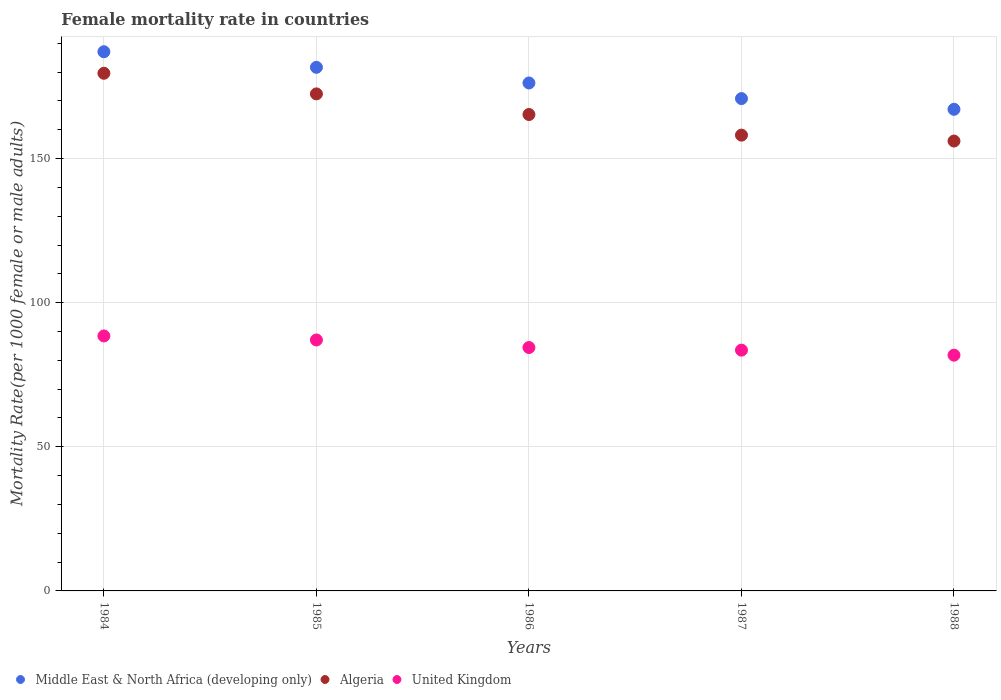Is the number of dotlines equal to the number of legend labels?
Give a very brief answer. Yes. What is the female mortality rate in United Kingdom in 1988?
Offer a very short reply. 81.79. Across all years, what is the maximum female mortality rate in Algeria?
Your answer should be compact. 179.58. Across all years, what is the minimum female mortality rate in United Kingdom?
Your answer should be compact. 81.79. In which year was the female mortality rate in Middle East & North Africa (developing only) maximum?
Your answer should be very brief. 1984. What is the total female mortality rate in Middle East & North Africa (developing only) in the graph?
Make the answer very short. 882.79. What is the difference between the female mortality rate in Algeria in 1984 and that in 1988?
Ensure brevity in your answer.  23.52. What is the difference between the female mortality rate in United Kingdom in 1984 and the female mortality rate in Algeria in 1986?
Give a very brief answer. -76.82. What is the average female mortality rate in Middle East & North Africa (developing only) per year?
Ensure brevity in your answer.  176.56. In the year 1986, what is the difference between the female mortality rate in Middle East & North Africa (developing only) and female mortality rate in United Kingdom?
Give a very brief answer. 91.77. In how many years, is the female mortality rate in Algeria greater than 30?
Give a very brief answer. 5. What is the ratio of the female mortality rate in Middle East & North Africa (developing only) in 1984 to that in 1988?
Your answer should be compact. 1.12. What is the difference between the highest and the second highest female mortality rate in Algeria?
Keep it short and to the point. 7.16. What is the difference between the highest and the lowest female mortality rate in Middle East & North Africa (developing only)?
Offer a very short reply. 19.97. In how many years, is the female mortality rate in United Kingdom greater than the average female mortality rate in United Kingdom taken over all years?
Keep it short and to the point. 2. Does the female mortality rate in Middle East & North Africa (developing only) monotonically increase over the years?
Offer a very short reply. No. Is the female mortality rate in United Kingdom strictly greater than the female mortality rate in Middle East & North Africa (developing only) over the years?
Your response must be concise. No. How many dotlines are there?
Your answer should be compact. 3. How many years are there in the graph?
Offer a terse response. 5. Are the values on the major ticks of Y-axis written in scientific E-notation?
Your answer should be compact. No. What is the title of the graph?
Provide a succinct answer. Female mortality rate in countries. Does "Honduras" appear as one of the legend labels in the graph?
Give a very brief answer. No. What is the label or title of the Y-axis?
Offer a very short reply. Mortality Rate(per 1000 female or male adults). What is the Mortality Rate(per 1000 female or male adults) in Middle East & North Africa (developing only) in 1984?
Give a very brief answer. 187.05. What is the Mortality Rate(per 1000 female or male adults) of Algeria in 1984?
Offer a terse response. 179.58. What is the Mortality Rate(per 1000 female or male adults) in United Kingdom in 1984?
Make the answer very short. 88.45. What is the Mortality Rate(per 1000 female or male adults) of Middle East & North Africa (developing only) in 1985?
Keep it short and to the point. 181.65. What is the Mortality Rate(per 1000 female or male adults) in Algeria in 1985?
Give a very brief answer. 172.43. What is the Mortality Rate(per 1000 female or male adults) in United Kingdom in 1985?
Give a very brief answer. 87.06. What is the Mortality Rate(per 1000 female or male adults) in Middle East & North Africa (developing only) in 1986?
Offer a terse response. 176.21. What is the Mortality Rate(per 1000 female or male adults) in Algeria in 1986?
Give a very brief answer. 165.27. What is the Mortality Rate(per 1000 female or male adults) in United Kingdom in 1986?
Make the answer very short. 84.44. What is the Mortality Rate(per 1000 female or male adults) of Middle East & North Africa (developing only) in 1987?
Your answer should be compact. 170.8. What is the Mortality Rate(per 1000 female or male adults) of Algeria in 1987?
Provide a succinct answer. 158.12. What is the Mortality Rate(per 1000 female or male adults) of United Kingdom in 1987?
Provide a succinct answer. 83.53. What is the Mortality Rate(per 1000 female or male adults) of Middle East & North Africa (developing only) in 1988?
Offer a terse response. 167.08. What is the Mortality Rate(per 1000 female or male adults) in Algeria in 1988?
Keep it short and to the point. 156.07. What is the Mortality Rate(per 1000 female or male adults) of United Kingdom in 1988?
Provide a short and direct response. 81.79. Across all years, what is the maximum Mortality Rate(per 1000 female or male adults) in Middle East & North Africa (developing only)?
Make the answer very short. 187.05. Across all years, what is the maximum Mortality Rate(per 1000 female or male adults) of Algeria?
Provide a succinct answer. 179.58. Across all years, what is the maximum Mortality Rate(per 1000 female or male adults) in United Kingdom?
Provide a short and direct response. 88.45. Across all years, what is the minimum Mortality Rate(per 1000 female or male adults) of Middle East & North Africa (developing only)?
Make the answer very short. 167.08. Across all years, what is the minimum Mortality Rate(per 1000 female or male adults) of Algeria?
Your response must be concise. 156.07. Across all years, what is the minimum Mortality Rate(per 1000 female or male adults) in United Kingdom?
Give a very brief answer. 81.79. What is the total Mortality Rate(per 1000 female or male adults) in Middle East & North Africa (developing only) in the graph?
Your response must be concise. 882.79. What is the total Mortality Rate(per 1000 female or male adults) in Algeria in the graph?
Ensure brevity in your answer.  831.48. What is the total Mortality Rate(per 1000 female or male adults) of United Kingdom in the graph?
Give a very brief answer. 425.27. What is the difference between the Mortality Rate(per 1000 female or male adults) of Middle East & North Africa (developing only) in 1984 and that in 1985?
Offer a terse response. 5.4. What is the difference between the Mortality Rate(per 1000 female or male adults) in Algeria in 1984 and that in 1985?
Give a very brief answer. 7.16. What is the difference between the Mortality Rate(per 1000 female or male adults) in United Kingdom in 1984 and that in 1985?
Your answer should be very brief. 1.39. What is the difference between the Mortality Rate(per 1000 female or male adults) in Middle East & North Africa (developing only) in 1984 and that in 1986?
Offer a very short reply. 10.83. What is the difference between the Mortality Rate(per 1000 female or male adults) in Algeria in 1984 and that in 1986?
Give a very brief answer. 14.31. What is the difference between the Mortality Rate(per 1000 female or male adults) of United Kingdom in 1984 and that in 1986?
Keep it short and to the point. 4.01. What is the difference between the Mortality Rate(per 1000 female or male adults) of Middle East & North Africa (developing only) in 1984 and that in 1987?
Keep it short and to the point. 16.25. What is the difference between the Mortality Rate(per 1000 female or male adults) of Algeria in 1984 and that in 1987?
Make the answer very short. 21.46. What is the difference between the Mortality Rate(per 1000 female or male adults) of United Kingdom in 1984 and that in 1987?
Keep it short and to the point. 4.92. What is the difference between the Mortality Rate(per 1000 female or male adults) of Middle East & North Africa (developing only) in 1984 and that in 1988?
Give a very brief answer. 19.97. What is the difference between the Mortality Rate(per 1000 female or male adults) in Algeria in 1984 and that in 1988?
Give a very brief answer. 23.52. What is the difference between the Mortality Rate(per 1000 female or male adults) of United Kingdom in 1984 and that in 1988?
Make the answer very short. 6.66. What is the difference between the Mortality Rate(per 1000 female or male adults) in Middle East & North Africa (developing only) in 1985 and that in 1986?
Ensure brevity in your answer.  5.43. What is the difference between the Mortality Rate(per 1000 female or male adults) of Algeria in 1985 and that in 1986?
Ensure brevity in your answer.  7.16. What is the difference between the Mortality Rate(per 1000 female or male adults) in United Kingdom in 1985 and that in 1986?
Make the answer very short. 2.62. What is the difference between the Mortality Rate(per 1000 female or male adults) in Middle East & North Africa (developing only) in 1985 and that in 1987?
Make the answer very short. 10.85. What is the difference between the Mortality Rate(per 1000 female or male adults) of Algeria in 1985 and that in 1987?
Provide a succinct answer. 14.31. What is the difference between the Mortality Rate(per 1000 female or male adults) in United Kingdom in 1985 and that in 1987?
Your answer should be very brief. 3.53. What is the difference between the Mortality Rate(per 1000 female or male adults) of Middle East & North Africa (developing only) in 1985 and that in 1988?
Your answer should be very brief. 14.57. What is the difference between the Mortality Rate(per 1000 female or male adults) in Algeria in 1985 and that in 1988?
Give a very brief answer. 16.36. What is the difference between the Mortality Rate(per 1000 female or male adults) in United Kingdom in 1985 and that in 1988?
Your response must be concise. 5.27. What is the difference between the Mortality Rate(per 1000 female or male adults) in Middle East & North Africa (developing only) in 1986 and that in 1987?
Make the answer very short. 5.42. What is the difference between the Mortality Rate(per 1000 female or male adults) of Algeria in 1986 and that in 1987?
Give a very brief answer. 7.16. What is the difference between the Mortality Rate(per 1000 female or male adults) of United Kingdom in 1986 and that in 1987?
Give a very brief answer. 0.91. What is the difference between the Mortality Rate(per 1000 female or male adults) in Middle East & North Africa (developing only) in 1986 and that in 1988?
Give a very brief answer. 9.13. What is the difference between the Mortality Rate(per 1000 female or male adults) in Algeria in 1986 and that in 1988?
Ensure brevity in your answer.  9.21. What is the difference between the Mortality Rate(per 1000 female or male adults) of United Kingdom in 1986 and that in 1988?
Your answer should be compact. 2.65. What is the difference between the Mortality Rate(per 1000 female or male adults) of Middle East & North Africa (developing only) in 1987 and that in 1988?
Keep it short and to the point. 3.72. What is the difference between the Mortality Rate(per 1000 female or male adults) of Algeria in 1987 and that in 1988?
Your response must be concise. 2.05. What is the difference between the Mortality Rate(per 1000 female or male adults) in United Kingdom in 1987 and that in 1988?
Offer a terse response. 1.74. What is the difference between the Mortality Rate(per 1000 female or male adults) of Middle East & North Africa (developing only) in 1984 and the Mortality Rate(per 1000 female or male adults) of Algeria in 1985?
Provide a short and direct response. 14.62. What is the difference between the Mortality Rate(per 1000 female or male adults) in Middle East & North Africa (developing only) in 1984 and the Mortality Rate(per 1000 female or male adults) in United Kingdom in 1985?
Keep it short and to the point. 99.99. What is the difference between the Mortality Rate(per 1000 female or male adults) of Algeria in 1984 and the Mortality Rate(per 1000 female or male adults) of United Kingdom in 1985?
Keep it short and to the point. 92.52. What is the difference between the Mortality Rate(per 1000 female or male adults) in Middle East & North Africa (developing only) in 1984 and the Mortality Rate(per 1000 female or male adults) in Algeria in 1986?
Your response must be concise. 21.77. What is the difference between the Mortality Rate(per 1000 female or male adults) of Middle East & North Africa (developing only) in 1984 and the Mortality Rate(per 1000 female or male adults) of United Kingdom in 1986?
Provide a succinct answer. 102.61. What is the difference between the Mortality Rate(per 1000 female or male adults) of Algeria in 1984 and the Mortality Rate(per 1000 female or male adults) of United Kingdom in 1986?
Offer a very short reply. 95.14. What is the difference between the Mortality Rate(per 1000 female or male adults) in Middle East & North Africa (developing only) in 1984 and the Mortality Rate(per 1000 female or male adults) in Algeria in 1987?
Provide a short and direct response. 28.93. What is the difference between the Mortality Rate(per 1000 female or male adults) of Middle East & North Africa (developing only) in 1984 and the Mortality Rate(per 1000 female or male adults) of United Kingdom in 1987?
Make the answer very short. 103.52. What is the difference between the Mortality Rate(per 1000 female or male adults) in Algeria in 1984 and the Mortality Rate(per 1000 female or male adults) in United Kingdom in 1987?
Provide a succinct answer. 96.05. What is the difference between the Mortality Rate(per 1000 female or male adults) in Middle East & North Africa (developing only) in 1984 and the Mortality Rate(per 1000 female or male adults) in Algeria in 1988?
Provide a short and direct response. 30.98. What is the difference between the Mortality Rate(per 1000 female or male adults) of Middle East & North Africa (developing only) in 1984 and the Mortality Rate(per 1000 female or male adults) of United Kingdom in 1988?
Ensure brevity in your answer.  105.26. What is the difference between the Mortality Rate(per 1000 female or male adults) in Algeria in 1984 and the Mortality Rate(per 1000 female or male adults) in United Kingdom in 1988?
Make the answer very short. 97.79. What is the difference between the Mortality Rate(per 1000 female or male adults) in Middle East & North Africa (developing only) in 1985 and the Mortality Rate(per 1000 female or male adults) in Algeria in 1986?
Offer a terse response. 16.37. What is the difference between the Mortality Rate(per 1000 female or male adults) of Middle East & North Africa (developing only) in 1985 and the Mortality Rate(per 1000 female or male adults) of United Kingdom in 1986?
Make the answer very short. 97.21. What is the difference between the Mortality Rate(per 1000 female or male adults) of Algeria in 1985 and the Mortality Rate(per 1000 female or male adults) of United Kingdom in 1986?
Ensure brevity in your answer.  87.99. What is the difference between the Mortality Rate(per 1000 female or male adults) in Middle East & North Africa (developing only) in 1985 and the Mortality Rate(per 1000 female or male adults) in Algeria in 1987?
Your answer should be compact. 23.53. What is the difference between the Mortality Rate(per 1000 female or male adults) of Middle East & North Africa (developing only) in 1985 and the Mortality Rate(per 1000 female or male adults) of United Kingdom in 1987?
Provide a succinct answer. 98.12. What is the difference between the Mortality Rate(per 1000 female or male adults) of Algeria in 1985 and the Mortality Rate(per 1000 female or male adults) of United Kingdom in 1987?
Provide a succinct answer. 88.9. What is the difference between the Mortality Rate(per 1000 female or male adults) in Middle East & North Africa (developing only) in 1985 and the Mortality Rate(per 1000 female or male adults) in Algeria in 1988?
Your answer should be very brief. 25.58. What is the difference between the Mortality Rate(per 1000 female or male adults) in Middle East & North Africa (developing only) in 1985 and the Mortality Rate(per 1000 female or male adults) in United Kingdom in 1988?
Make the answer very short. 99.86. What is the difference between the Mortality Rate(per 1000 female or male adults) in Algeria in 1985 and the Mortality Rate(per 1000 female or male adults) in United Kingdom in 1988?
Offer a terse response. 90.64. What is the difference between the Mortality Rate(per 1000 female or male adults) of Middle East & North Africa (developing only) in 1986 and the Mortality Rate(per 1000 female or male adults) of Algeria in 1987?
Provide a succinct answer. 18.09. What is the difference between the Mortality Rate(per 1000 female or male adults) of Middle East & North Africa (developing only) in 1986 and the Mortality Rate(per 1000 female or male adults) of United Kingdom in 1987?
Give a very brief answer. 92.68. What is the difference between the Mortality Rate(per 1000 female or male adults) of Algeria in 1986 and the Mortality Rate(per 1000 female or male adults) of United Kingdom in 1987?
Your response must be concise. 81.74. What is the difference between the Mortality Rate(per 1000 female or male adults) of Middle East & North Africa (developing only) in 1986 and the Mortality Rate(per 1000 female or male adults) of Algeria in 1988?
Ensure brevity in your answer.  20.14. What is the difference between the Mortality Rate(per 1000 female or male adults) in Middle East & North Africa (developing only) in 1986 and the Mortality Rate(per 1000 female or male adults) in United Kingdom in 1988?
Make the answer very short. 94.42. What is the difference between the Mortality Rate(per 1000 female or male adults) in Algeria in 1986 and the Mortality Rate(per 1000 female or male adults) in United Kingdom in 1988?
Your answer should be compact. 83.48. What is the difference between the Mortality Rate(per 1000 female or male adults) of Middle East & North Africa (developing only) in 1987 and the Mortality Rate(per 1000 female or male adults) of Algeria in 1988?
Your answer should be compact. 14.73. What is the difference between the Mortality Rate(per 1000 female or male adults) of Middle East & North Africa (developing only) in 1987 and the Mortality Rate(per 1000 female or male adults) of United Kingdom in 1988?
Your answer should be very brief. 89.01. What is the difference between the Mortality Rate(per 1000 female or male adults) of Algeria in 1987 and the Mortality Rate(per 1000 female or male adults) of United Kingdom in 1988?
Keep it short and to the point. 76.33. What is the average Mortality Rate(per 1000 female or male adults) of Middle East & North Africa (developing only) per year?
Your answer should be very brief. 176.56. What is the average Mortality Rate(per 1000 female or male adults) in Algeria per year?
Your answer should be compact. 166.29. What is the average Mortality Rate(per 1000 female or male adults) in United Kingdom per year?
Your response must be concise. 85.06. In the year 1984, what is the difference between the Mortality Rate(per 1000 female or male adults) of Middle East & North Africa (developing only) and Mortality Rate(per 1000 female or male adults) of Algeria?
Your response must be concise. 7.46. In the year 1984, what is the difference between the Mortality Rate(per 1000 female or male adults) in Middle East & North Africa (developing only) and Mortality Rate(per 1000 female or male adults) in United Kingdom?
Keep it short and to the point. 98.6. In the year 1984, what is the difference between the Mortality Rate(per 1000 female or male adults) in Algeria and Mortality Rate(per 1000 female or male adults) in United Kingdom?
Ensure brevity in your answer.  91.13. In the year 1985, what is the difference between the Mortality Rate(per 1000 female or male adults) of Middle East & North Africa (developing only) and Mortality Rate(per 1000 female or male adults) of Algeria?
Give a very brief answer. 9.22. In the year 1985, what is the difference between the Mortality Rate(per 1000 female or male adults) of Middle East & North Africa (developing only) and Mortality Rate(per 1000 female or male adults) of United Kingdom?
Your answer should be very brief. 94.59. In the year 1985, what is the difference between the Mortality Rate(per 1000 female or male adults) in Algeria and Mortality Rate(per 1000 female or male adults) in United Kingdom?
Give a very brief answer. 85.37. In the year 1986, what is the difference between the Mortality Rate(per 1000 female or male adults) of Middle East & North Africa (developing only) and Mortality Rate(per 1000 female or male adults) of Algeria?
Offer a very short reply. 10.94. In the year 1986, what is the difference between the Mortality Rate(per 1000 female or male adults) in Middle East & North Africa (developing only) and Mortality Rate(per 1000 female or male adults) in United Kingdom?
Ensure brevity in your answer.  91.77. In the year 1986, what is the difference between the Mortality Rate(per 1000 female or male adults) in Algeria and Mortality Rate(per 1000 female or male adults) in United Kingdom?
Provide a short and direct response. 80.83. In the year 1987, what is the difference between the Mortality Rate(per 1000 female or male adults) in Middle East & North Africa (developing only) and Mortality Rate(per 1000 female or male adults) in Algeria?
Provide a succinct answer. 12.68. In the year 1987, what is the difference between the Mortality Rate(per 1000 female or male adults) of Middle East & North Africa (developing only) and Mortality Rate(per 1000 female or male adults) of United Kingdom?
Provide a short and direct response. 87.26. In the year 1987, what is the difference between the Mortality Rate(per 1000 female or male adults) in Algeria and Mortality Rate(per 1000 female or male adults) in United Kingdom?
Offer a very short reply. 74.59. In the year 1988, what is the difference between the Mortality Rate(per 1000 female or male adults) of Middle East & North Africa (developing only) and Mortality Rate(per 1000 female or male adults) of Algeria?
Your answer should be very brief. 11.01. In the year 1988, what is the difference between the Mortality Rate(per 1000 female or male adults) of Middle East & North Africa (developing only) and Mortality Rate(per 1000 female or male adults) of United Kingdom?
Provide a succinct answer. 85.29. In the year 1988, what is the difference between the Mortality Rate(per 1000 female or male adults) of Algeria and Mortality Rate(per 1000 female or male adults) of United Kingdom?
Ensure brevity in your answer.  74.28. What is the ratio of the Mortality Rate(per 1000 female or male adults) of Middle East & North Africa (developing only) in 1984 to that in 1985?
Provide a short and direct response. 1.03. What is the ratio of the Mortality Rate(per 1000 female or male adults) of Algeria in 1984 to that in 1985?
Keep it short and to the point. 1.04. What is the ratio of the Mortality Rate(per 1000 female or male adults) in Middle East & North Africa (developing only) in 1984 to that in 1986?
Offer a terse response. 1.06. What is the ratio of the Mortality Rate(per 1000 female or male adults) in Algeria in 1984 to that in 1986?
Your answer should be compact. 1.09. What is the ratio of the Mortality Rate(per 1000 female or male adults) of United Kingdom in 1984 to that in 1986?
Offer a very short reply. 1.05. What is the ratio of the Mortality Rate(per 1000 female or male adults) of Middle East & North Africa (developing only) in 1984 to that in 1987?
Give a very brief answer. 1.1. What is the ratio of the Mortality Rate(per 1000 female or male adults) of Algeria in 1984 to that in 1987?
Make the answer very short. 1.14. What is the ratio of the Mortality Rate(per 1000 female or male adults) in United Kingdom in 1984 to that in 1987?
Offer a very short reply. 1.06. What is the ratio of the Mortality Rate(per 1000 female or male adults) of Middle East & North Africa (developing only) in 1984 to that in 1988?
Make the answer very short. 1.12. What is the ratio of the Mortality Rate(per 1000 female or male adults) of Algeria in 1984 to that in 1988?
Give a very brief answer. 1.15. What is the ratio of the Mortality Rate(per 1000 female or male adults) in United Kingdom in 1984 to that in 1988?
Your answer should be compact. 1.08. What is the ratio of the Mortality Rate(per 1000 female or male adults) of Middle East & North Africa (developing only) in 1985 to that in 1986?
Keep it short and to the point. 1.03. What is the ratio of the Mortality Rate(per 1000 female or male adults) in Algeria in 1985 to that in 1986?
Ensure brevity in your answer.  1.04. What is the ratio of the Mortality Rate(per 1000 female or male adults) of United Kingdom in 1985 to that in 1986?
Provide a short and direct response. 1.03. What is the ratio of the Mortality Rate(per 1000 female or male adults) in Middle East & North Africa (developing only) in 1985 to that in 1987?
Provide a succinct answer. 1.06. What is the ratio of the Mortality Rate(per 1000 female or male adults) of Algeria in 1985 to that in 1987?
Offer a terse response. 1.09. What is the ratio of the Mortality Rate(per 1000 female or male adults) in United Kingdom in 1985 to that in 1987?
Ensure brevity in your answer.  1.04. What is the ratio of the Mortality Rate(per 1000 female or male adults) in Middle East & North Africa (developing only) in 1985 to that in 1988?
Offer a terse response. 1.09. What is the ratio of the Mortality Rate(per 1000 female or male adults) of Algeria in 1985 to that in 1988?
Offer a very short reply. 1.1. What is the ratio of the Mortality Rate(per 1000 female or male adults) in United Kingdom in 1985 to that in 1988?
Your response must be concise. 1.06. What is the ratio of the Mortality Rate(per 1000 female or male adults) in Middle East & North Africa (developing only) in 1986 to that in 1987?
Give a very brief answer. 1.03. What is the ratio of the Mortality Rate(per 1000 female or male adults) in Algeria in 1986 to that in 1987?
Your answer should be very brief. 1.05. What is the ratio of the Mortality Rate(per 1000 female or male adults) of United Kingdom in 1986 to that in 1987?
Make the answer very short. 1.01. What is the ratio of the Mortality Rate(per 1000 female or male adults) in Middle East & North Africa (developing only) in 1986 to that in 1988?
Make the answer very short. 1.05. What is the ratio of the Mortality Rate(per 1000 female or male adults) in Algeria in 1986 to that in 1988?
Ensure brevity in your answer.  1.06. What is the ratio of the Mortality Rate(per 1000 female or male adults) in United Kingdom in 1986 to that in 1988?
Provide a short and direct response. 1.03. What is the ratio of the Mortality Rate(per 1000 female or male adults) in Middle East & North Africa (developing only) in 1987 to that in 1988?
Keep it short and to the point. 1.02. What is the ratio of the Mortality Rate(per 1000 female or male adults) in Algeria in 1987 to that in 1988?
Your answer should be very brief. 1.01. What is the ratio of the Mortality Rate(per 1000 female or male adults) of United Kingdom in 1987 to that in 1988?
Provide a succinct answer. 1.02. What is the difference between the highest and the second highest Mortality Rate(per 1000 female or male adults) in Middle East & North Africa (developing only)?
Provide a succinct answer. 5.4. What is the difference between the highest and the second highest Mortality Rate(per 1000 female or male adults) of Algeria?
Provide a succinct answer. 7.16. What is the difference between the highest and the second highest Mortality Rate(per 1000 female or male adults) of United Kingdom?
Your answer should be very brief. 1.39. What is the difference between the highest and the lowest Mortality Rate(per 1000 female or male adults) in Middle East & North Africa (developing only)?
Ensure brevity in your answer.  19.97. What is the difference between the highest and the lowest Mortality Rate(per 1000 female or male adults) of Algeria?
Your response must be concise. 23.52. What is the difference between the highest and the lowest Mortality Rate(per 1000 female or male adults) of United Kingdom?
Offer a terse response. 6.66. 